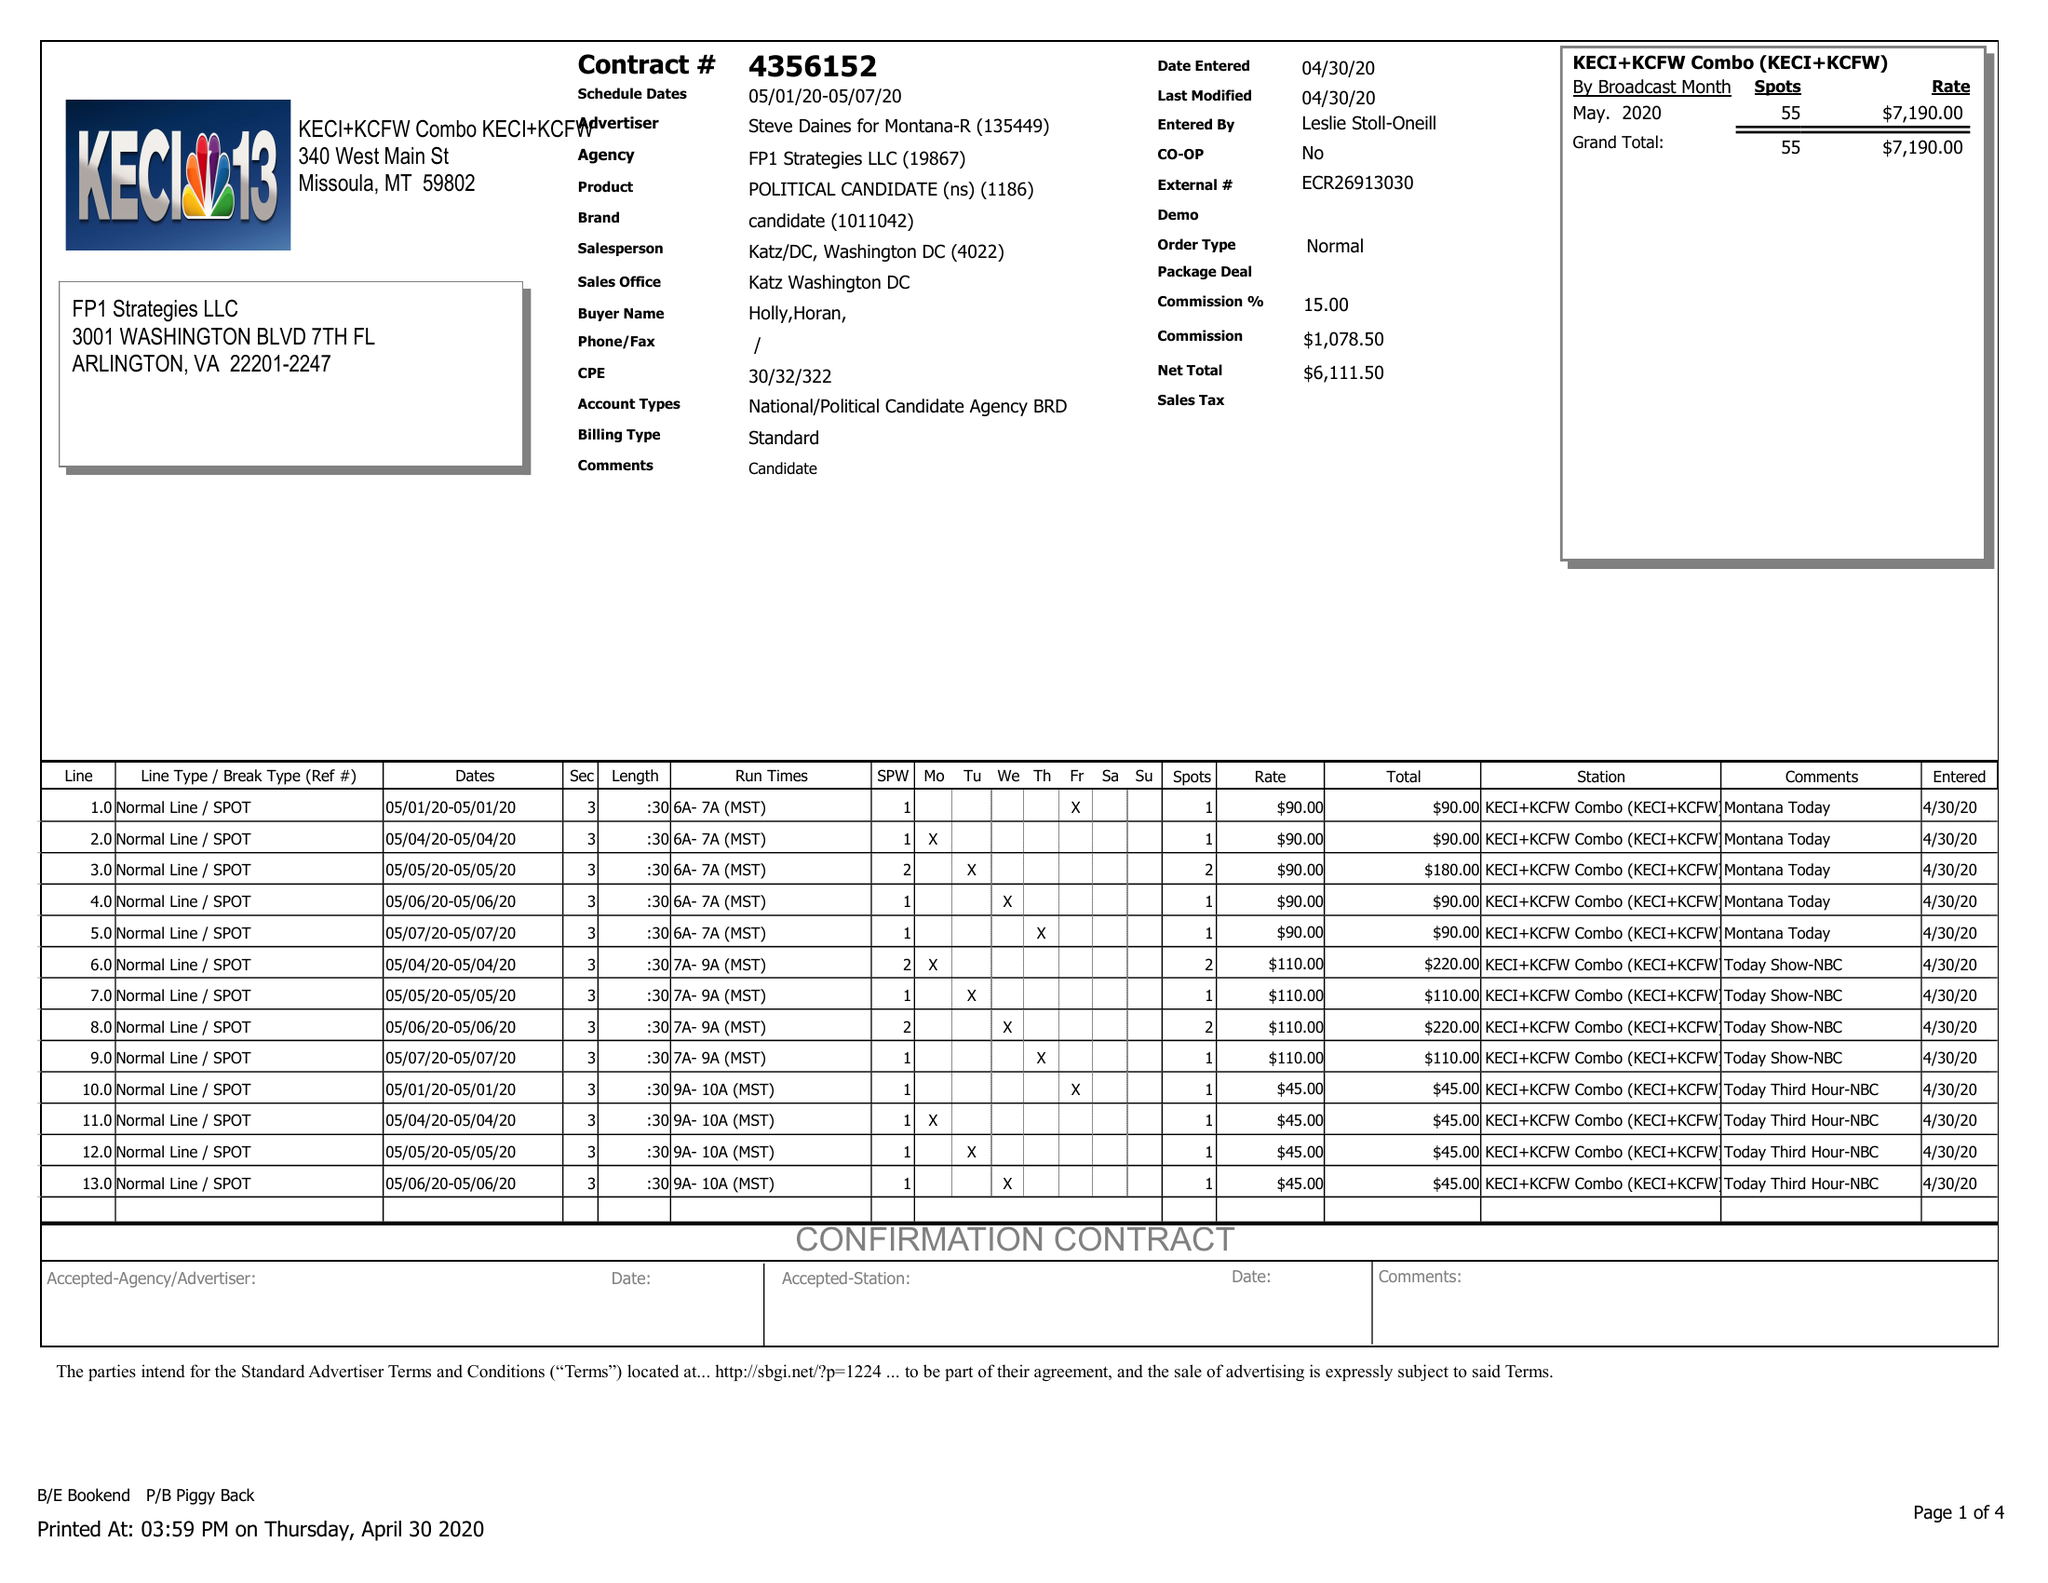What is the value for the contract_num?
Answer the question using a single word or phrase. 4356152 